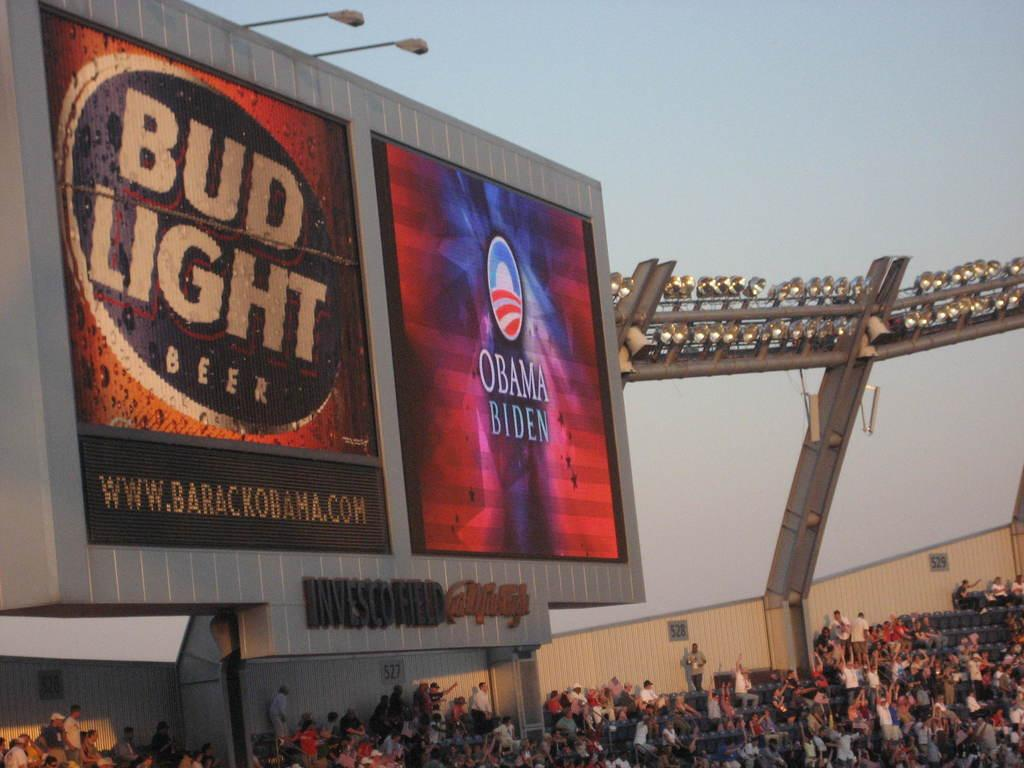<image>
Offer a succinct explanation of the picture presented. An advertisement on an outdoor screen that says Bud Light beer 